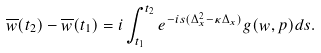Convert formula to latex. <formula><loc_0><loc_0><loc_500><loc_500>\overline { w } ( t _ { 2 } ) - \overline { w } ( t _ { 1 } ) = i \int _ { t _ { 1 } } ^ { t _ { 2 } } e ^ { - i s ( \Delta ^ { 2 } _ { x } - \kappa \Delta _ { x } ) } g ( w , p ) d s .</formula> 